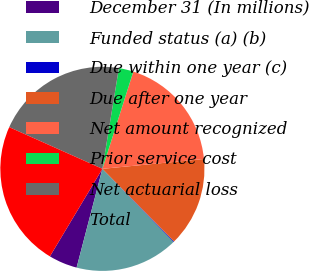Convert chart to OTSL. <chart><loc_0><loc_0><loc_500><loc_500><pie_chart><fcel>December 31 (In millions)<fcel>Funded status (a) (b)<fcel>Due within one year (c)<fcel>Due after one year<fcel>Net amount recognized<fcel>Prior service cost<fcel>Net actuarial loss<fcel>Total<nl><fcel>4.53%<fcel>16.35%<fcel>0.11%<fcel>14.14%<fcel>18.56%<fcel>2.32%<fcel>20.89%<fcel>23.1%<nl></chart> 